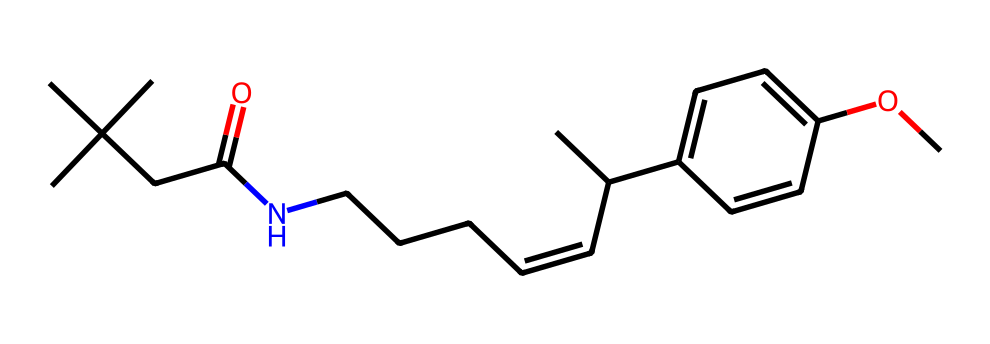how many carbon atoms are in capsaicin? In the provided SMILES representation, count the 'C's to determine the number of carbon atoms. There are 18 carbon atoms present in the structure.
Answer: 18 what is the functional group present in capsaicin? The presence of the C=O bond indicates that there is a carbonyl functional group (specifically a ketone or an amide) in the structure. In this case, it corresponds to the amide functional group due to its connection with a nitrogen atom.
Answer: amide which part of the chemical structure contributes to capsaicin's spiciness? The presence of the long hydrocarbon chain and the amide functional group is critical for the interaction with receptors that perceive heat, primarily the vanilloid receptor.
Answer: hydrocarbon chain what is the significance of the double bond in capsaicin? The double bond (C=C) in capsaicin contributes to the structural rigidity and influences how the molecule interacts with receptors and other substances, enhancing its bioactivity.
Answer: structural rigidity how many rings are present in capsaicin? In the given SMILES structure, there is one aromatic ring indicated by the notation with 'C1=CC=C(C=C1)', which indicates a cyclic structure with alternating double bonds.
Answer: one what is the molecular weight of capsaicin? To find the molecular weight, one can add the atomic weights of all atoms present in the structure. Capsaicin has a molecular weight of approximately 305.4 g/mol.
Answer: 305.4 g/mol 